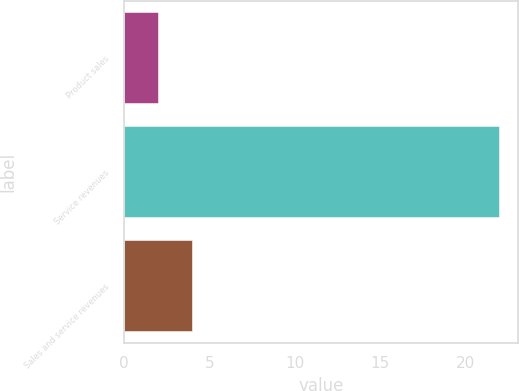<chart> <loc_0><loc_0><loc_500><loc_500><bar_chart><fcel>Product sales<fcel>Service revenues<fcel>Sales and service revenues<nl><fcel>2<fcel>22<fcel>4<nl></chart> 